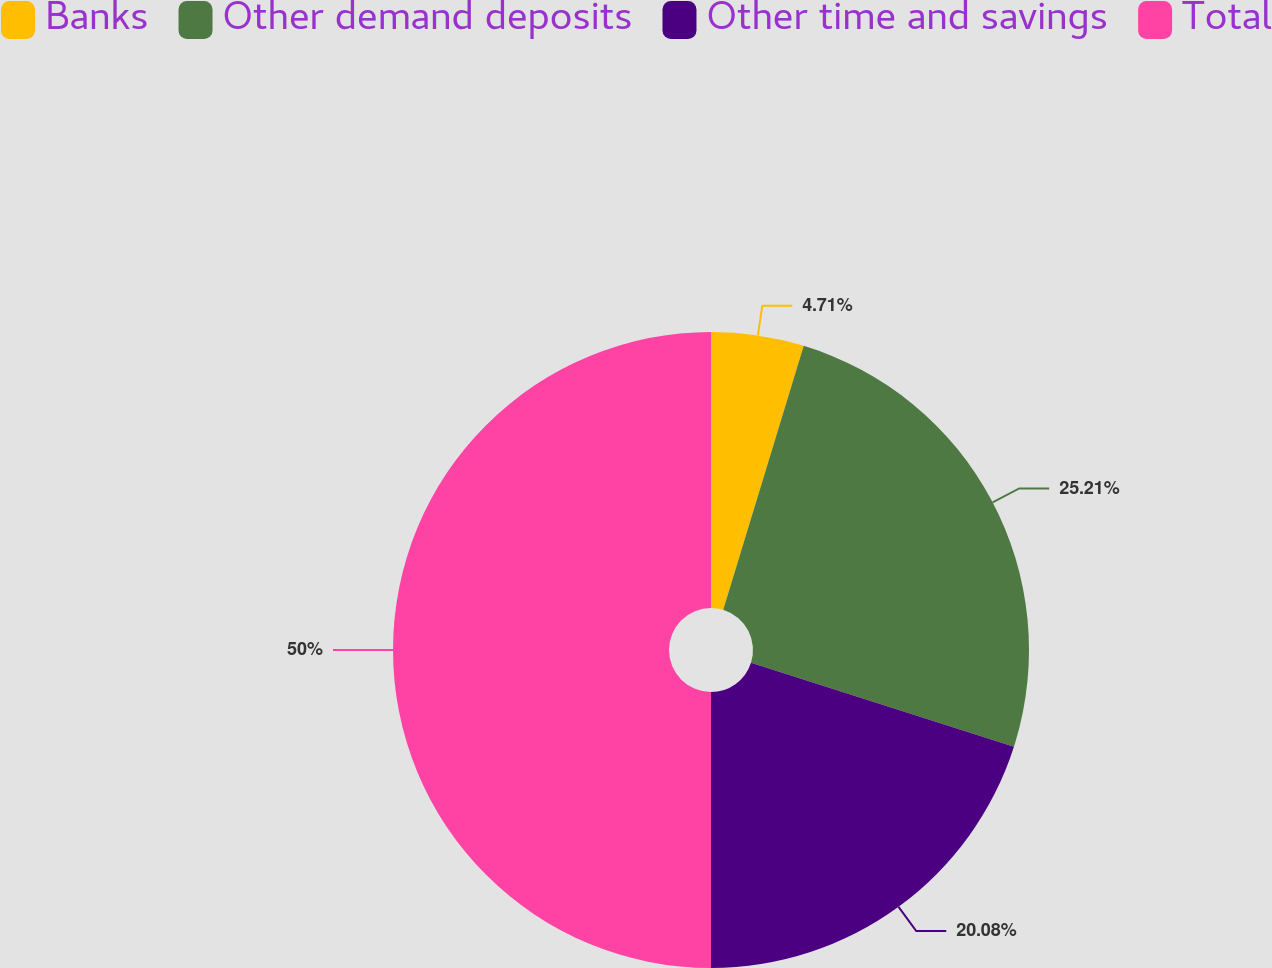<chart> <loc_0><loc_0><loc_500><loc_500><pie_chart><fcel>Banks<fcel>Other demand deposits<fcel>Other time and savings<fcel>Total<nl><fcel>4.71%<fcel>25.21%<fcel>20.08%<fcel>50.0%<nl></chart> 